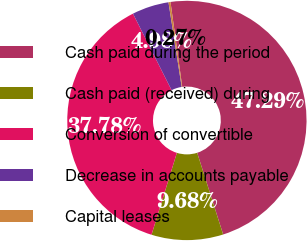<chart> <loc_0><loc_0><loc_500><loc_500><pie_chart><fcel>Cash paid during the period<fcel>Cash paid (received) during<fcel>Conversion of convertible<fcel>Decrease in accounts payable<fcel>Capital leases<nl><fcel>47.29%<fcel>9.68%<fcel>37.78%<fcel>4.98%<fcel>0.27%<nl></chart> 